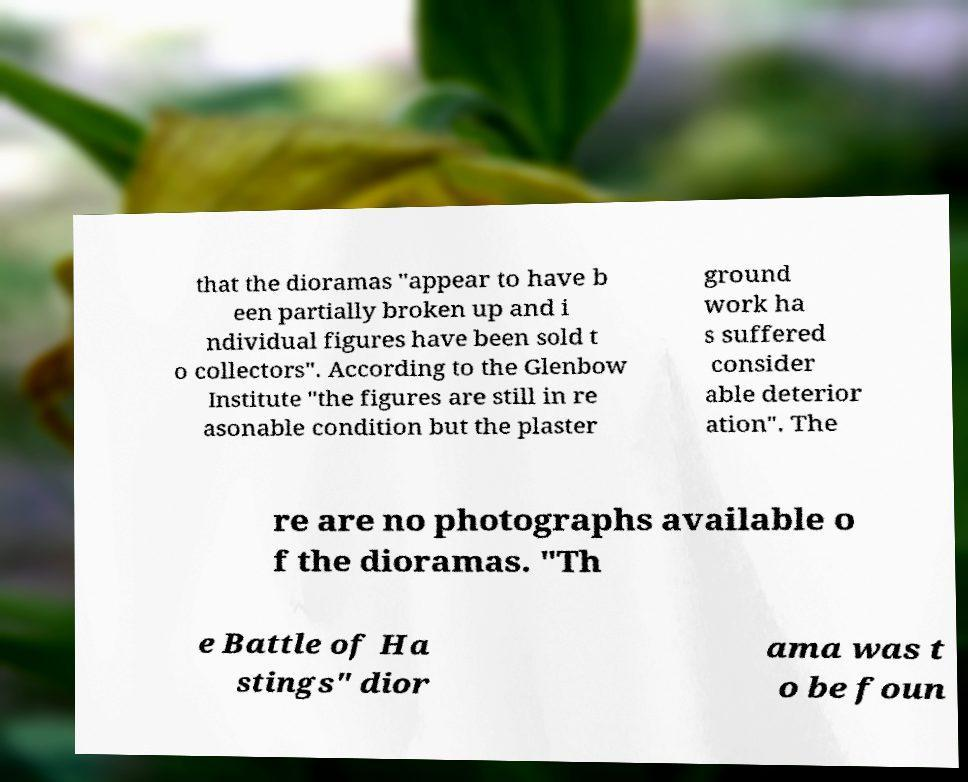Could you extract and type out the text from this image? that the dioramas "appear to have b een partially broken up and i ndividual figures have been sold t o collectors". According to the Glenbow Institute "the figures are still in re asonable condition but the plaster ground work ha s suffered consider able deterior ation". The re are no photographs available o f the dioramas. "Th e Battle of Ha stings" dior ama was t o be foun 